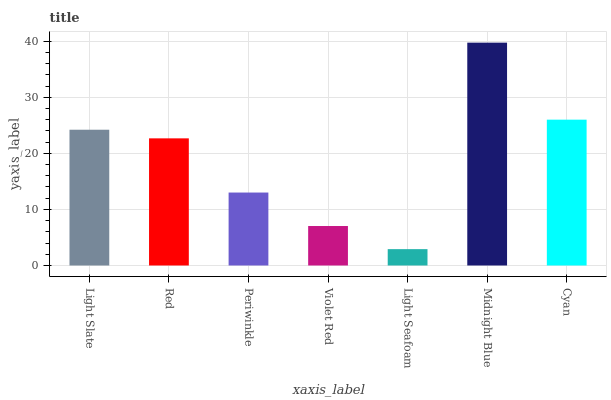Is Light Seafoam the minimum?
Answer yes or no. Yes. Is Midnight Blue the maximum?
Answer yes or no. Yes. Is Red the minimum?
Answer yes or no. No. Is Red the maximum?
Answer yes or no. No. Is Light Slate greater than Red?
Answer yes or no. Yes. Is Red less than Light Slate?
Answer yes or no. Yes. Is Red greater than Light Slate?
Answer yes or no. No. Is Light Slate less than Red?
Answer yes or no. No. Is Red the high median?
Answer yes or no. Yes. Is Red the low median?
Answer yes or no. Yes. Is Periwinkle the high median?
Answer yes or no. No. Is Light Seafoam the low median?
Answer yes or no. No. 